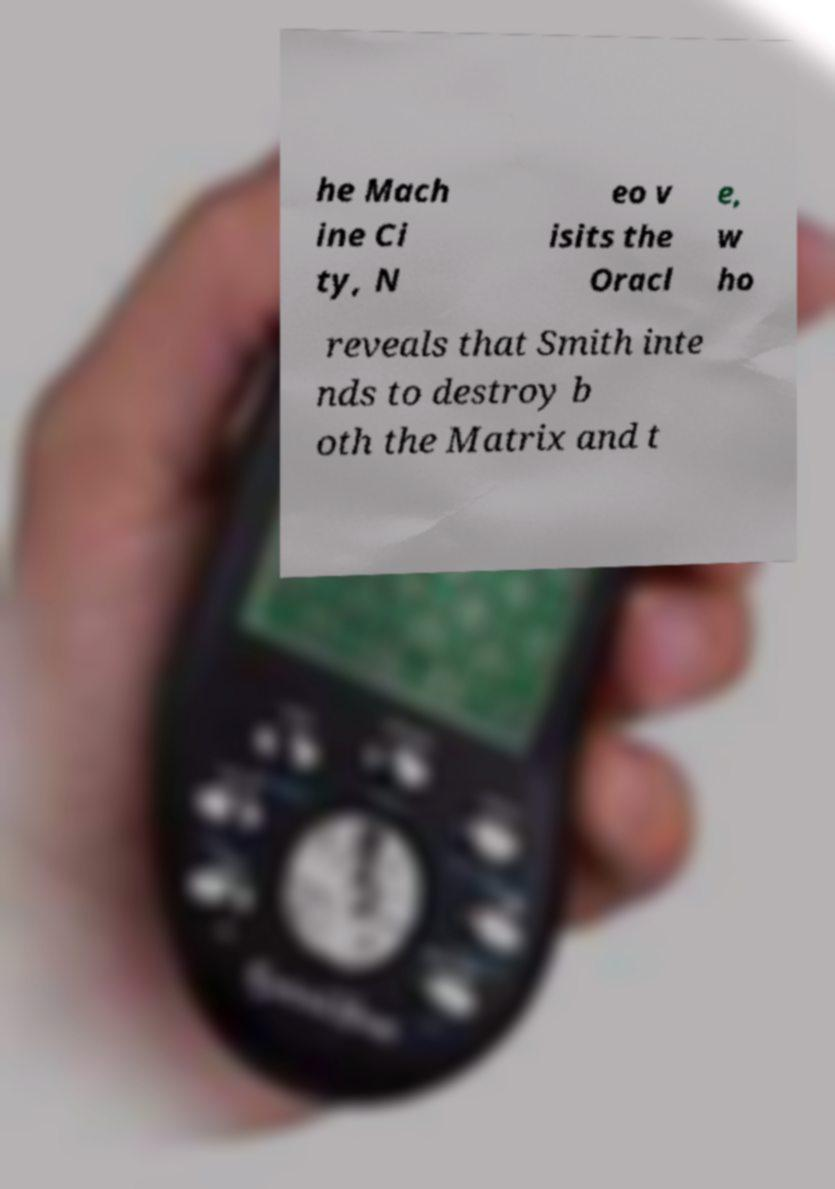For documentation purposes, I need the text within this image transcribed. Could you provide that? he Mach ine Ci ty, N eo v isits the Oracl e, w ho reveals that Smith inte nds to destroy b oth the Matrix and t 